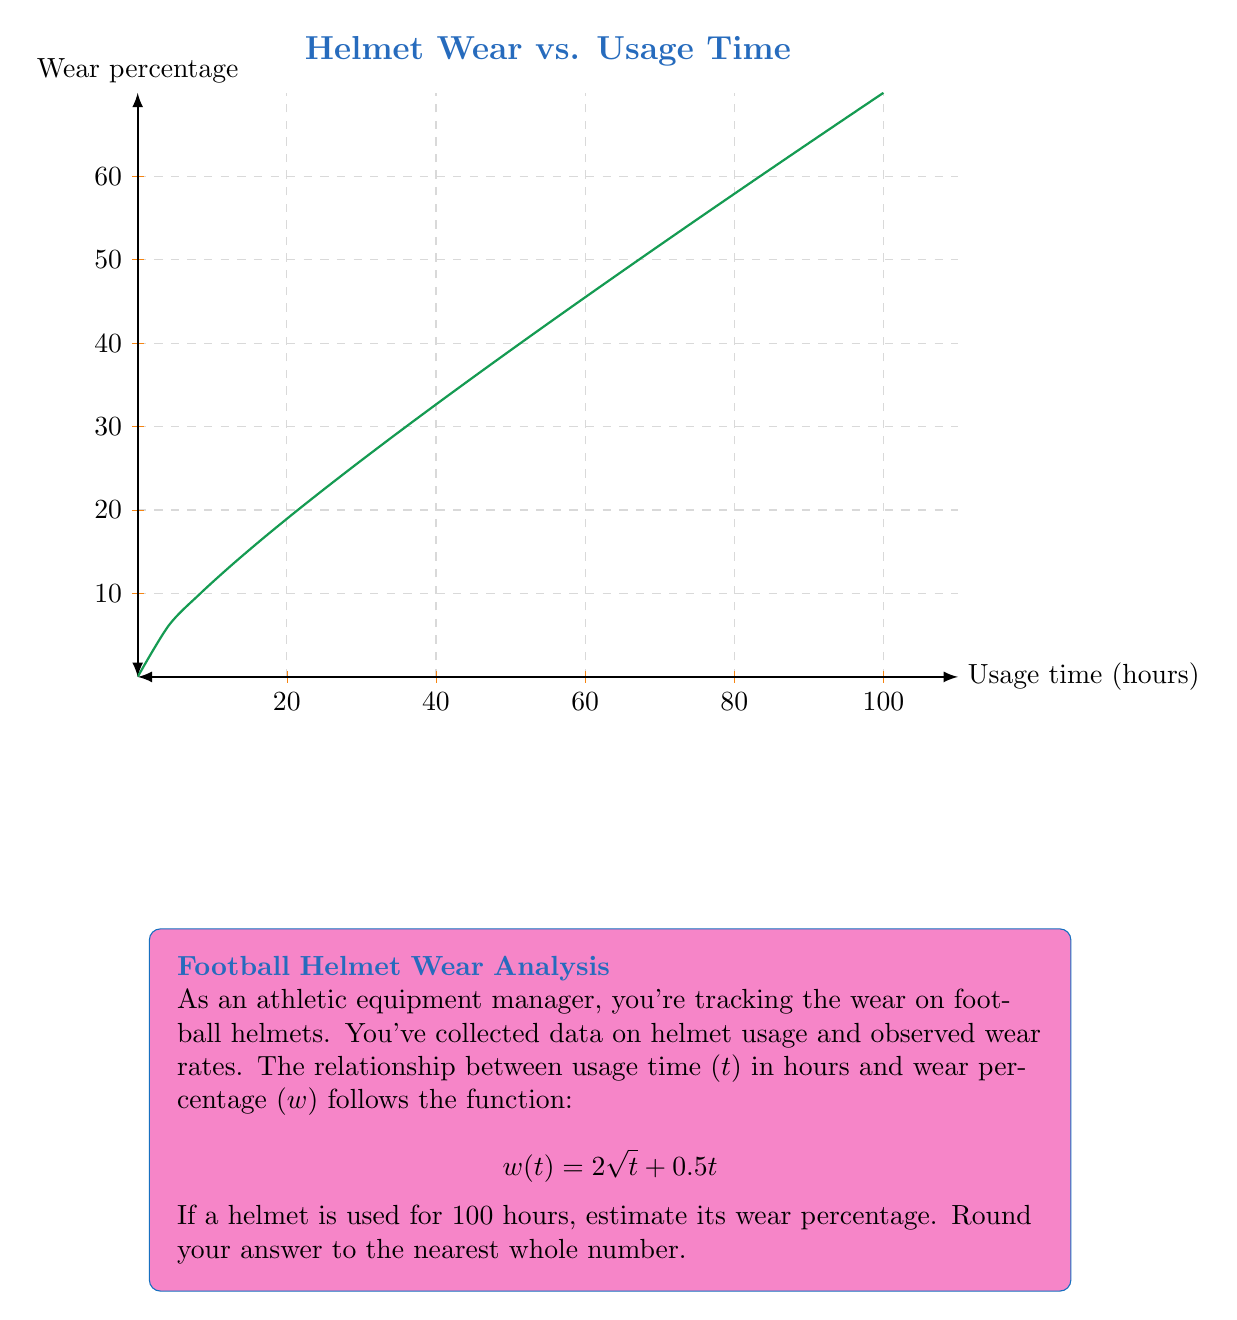What is the answer to this math problem? To solve this problem, we'll follow these steps:

1) We're given the wear function: $w(t) = 2\sqrt{t} + 0.5t$

2) We need to calculate $w(100)$, as we want to know the wear percentage after 100 hours of usage.

3) Let's substitute $t = 100$ into the function:

   $w(100) = 2\sqrt{100} + 0.5(100)$

4) Simplify:
   - $\sqrt{100} = 10$
   - $w(100) = 2(10) + 0.5(100)$
   - $w(100) = 20 + 50$
   - $w(100) = 70$

5) The question asks to round to the nearest whole number, but 70 is already a whole number.

Therefore, after 100 hours of usage, the estimated wear percentage of the helmet is 70%.
Answer: 70% 